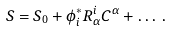<formula> <loc_0><loc_0><loc_500><loc_500>S = S _ { 0 } + \phi ^ { * } _ { i } R ^ { i } _ { \alpha } C ^ { \alpha } + \dots \, .</formula> 